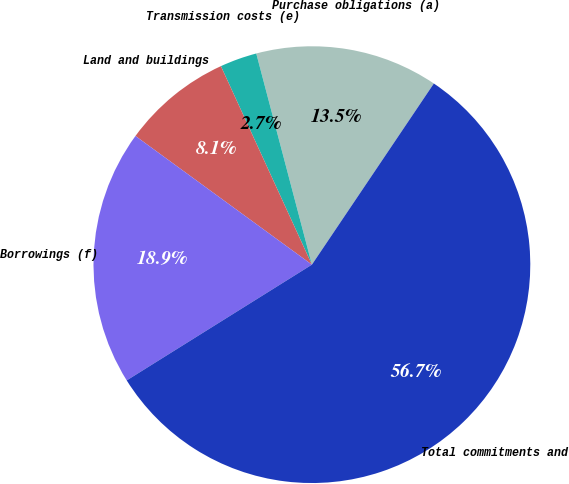<chart> <loc_0><loc_0><loc_500><loc_500><pie_chart><fcel>Purchase obligations (a)<fcel>Transmission costs (e)<fcel>Land and buildings<fcel>Borrowings (f)<fcel>Total commitments and<nl><fcel>13.53%<fcel>2.74%<fcel>8.13%<fcel>18.92%<fcel>56.68%<nl></chart> 